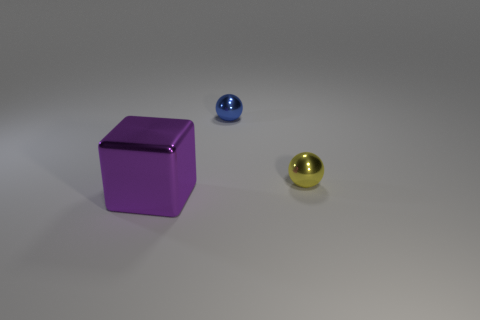Subtract all yellow spheres. Subtract all gray blocks. How many spheres are left? 1 Add 3 yellow cubes. How many objects exist? 6 Subtract all cubes. How many objects are left? 2 Add 1 small red metal blocks. How many small red metal blocks exist? 1 Subtract 0 gray balls. How many objects are left? 3 Subtract all red rubber objects. Subtract all blocks. How many objects are left? 2 Add 2 big purple shiny cubes. How many big purple shiny cubes are left? 3 